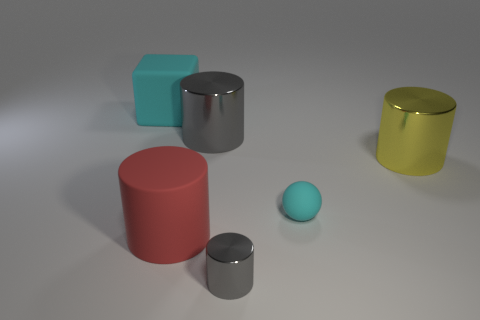Subtract all yellow metal cylinders. How many cylinders are left? 3 Add 4 gray shiny blocks. How many objects exist? 10 Subtract all blue balls. How many gray cylinders are left? 2 Subtract all red cylinders. How many cylinders are left? 3 Subtract 0 purple cylinders. How many objects are left? 6 Subtract all cylinders. How many objects are left? 2 Subtract 1 blocks. How many blocks are left? 0 Subtract all yellow balls. Subtract all cyan cylinders. How many balls are left? 1 Subtract all tiny rubber spheres. Subtract all yellow cylinders. How many objects are left? 4 Add 6 small cyan matte things. How many small cyan matte things are left? 7 